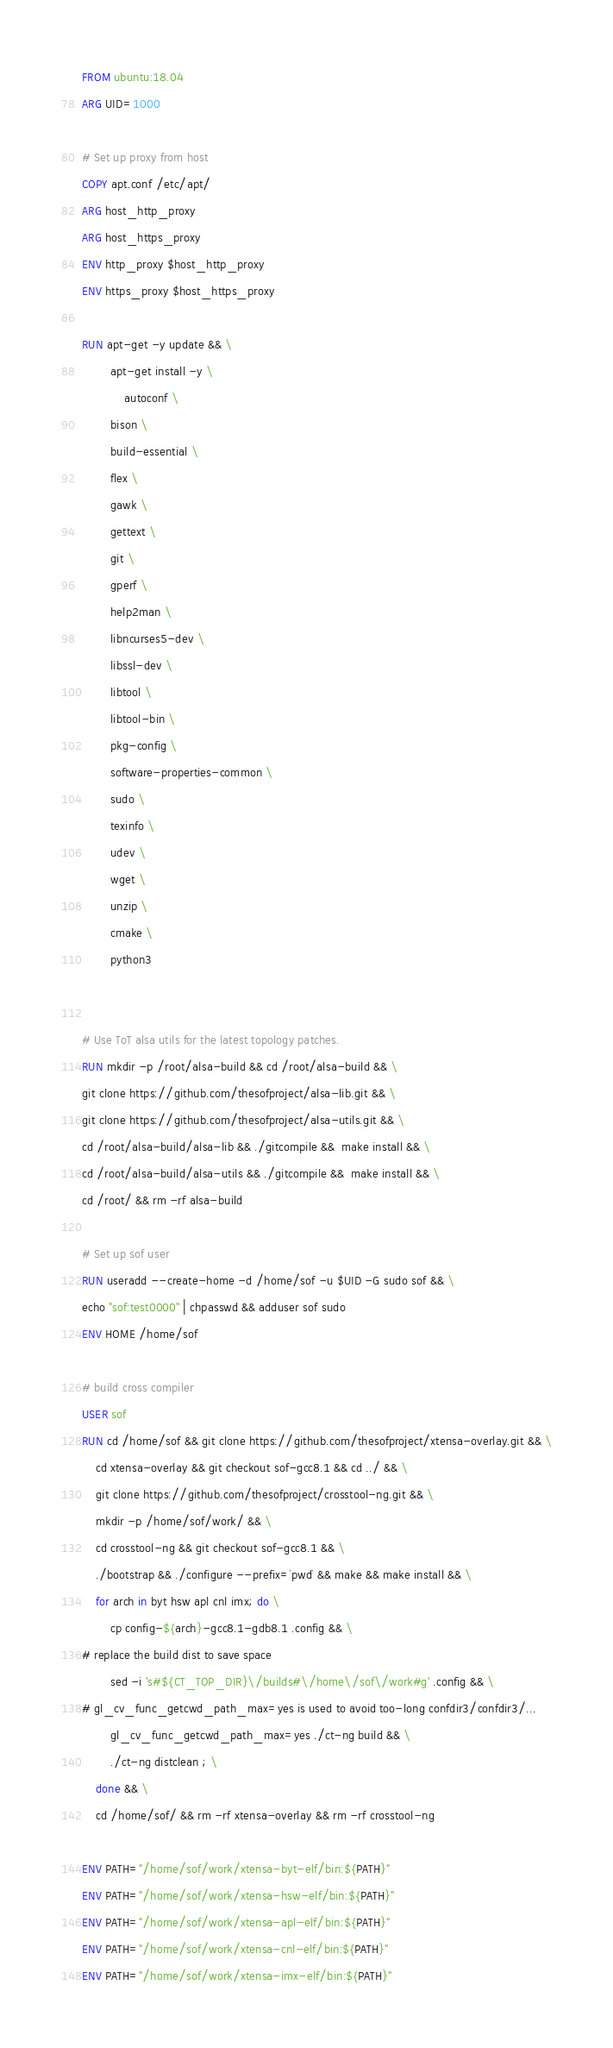Convert code to text. <code><loc_0><loc_0><loc_500><loc_500><_Dockerfile_>
FROM ubuntu:18.04
ARG UID=1000

# Set up proxy from host
COPY apt.conf /etc/apt/
ARG host_http_proxy
ARG host_https_proxy
ENV http_proxy $host_http_proxy
ENV https_proxy $host_https_proxy

RUN apt-get -y update && \
	    apt-get install -y \
	    	autoconf \
		bison \
		build-essential \
		flex \
		gawk \
		gettext \
		git \
		gperf \
		help2man \
		libncurses5-dev \
		libssl-dev \
		libtool \
		libtool-bin \
		pkg-config \
		software-properties-common \
		sudo \
		texinfo \
		udev \
		wget \
		unzip \
		cmake \
		python3


# Use ToT alsa utils for the latest topology patches.
RUN mkdir -p /root/alsa-build && cd /root/alsa-build && \
git clone https://github.com/thesofproject/alsa-lib.git && \
git clone https://github.com/thesofproject/alsa-utils.git && \
cd /root/alsa-build/alsa-lib && ./gitcompile &&  make install && \
cd /root/alsa-build/alsa-utils && ./gitcompile &&  make install && \
cd /root/ && rm -rf alsa-build

# Set up sof user
RUN useradd --create-home -d /home/sof -u $UID -G sudo sof && \
echo "sof:test0000" | chpasswd && adduser sof sudo
ENV HOME /home/sof

# build cross compiler
USER sof
RUN cd /home/sof && git clone https://github.com/thesofproject/xtensa-overlay.git && \
	cd xtensa-overlay && git checkout sof-gcc8.1 && cd ../ && \
	git clone https://github.com/thesofproject/crosstool-ng.git && \
	mkdir -p /home/sof/work/ && \
	cd crosstool-ng && git checkout sof-gcc8.1 && \
	./bootstrap && ./configure --prefix=`pwd` && make && make install && \
	for arch in byt hsw apl cnl imx; do \
		cp config-${arch}-gcc8.1-gdb8.1 .config && \
# replace the build dist to save space
		sed -i 's#${CT_TOP_DIR}\/builds#\/home\/sof\/work#g' .config && \
# gl_cv_func_getcwd_path_max=yes is used to avoid too-long confdir3/confdir3/...
		gl_cv_func_getcwd_path_max=yes ./ct-ng build && \
		./ct-ng distclean ; \
	done && \
	cd /home/sof/ && rm -rf xtensa-overlay && rm -rf crosstool-ng

ENV PATH="/home/sof/work/xtensa-byt-elf/bin:${PATH}"
ENV PATH="/home/sof/work/xtensa-hsw-elf/bin:${PATH}"
ENV PATH="/home/sof/work/xtensa-apl-elf/bin:${PATH}"
ENV PATH="/home/sof/work/xtensa-cnl-elf/bin:${PATH}"
ENV PATH="/home/sof/work/xtensa-imx-elf/bin:${PATH}"
</code> 